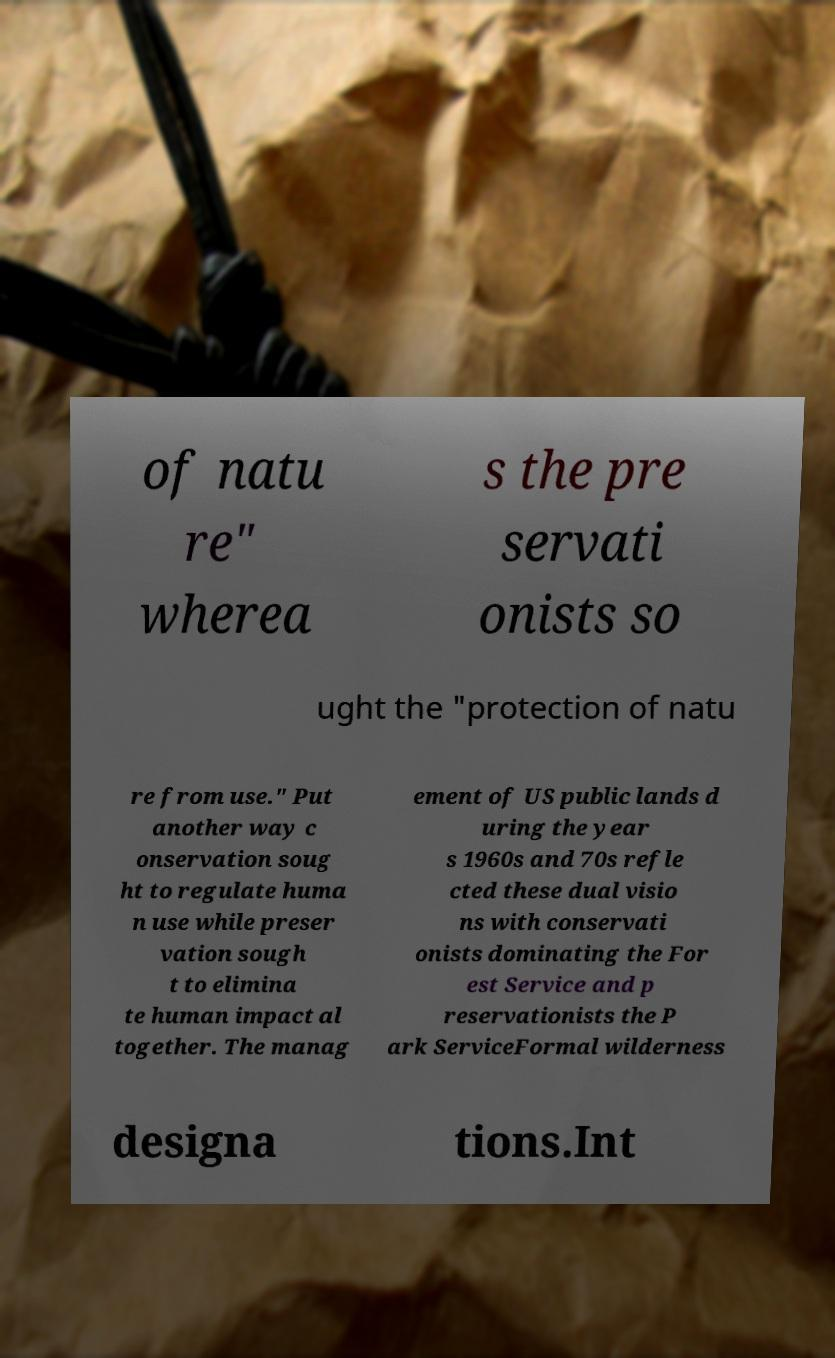For documentation purposes, I need the text within this image transcribed. Could you provide that? of natu re" wherea s the pre servati onists so ught the "protection of natu re from use." Put another way c onservation soug ht to regulate huma n use while preser vation sough t to elimina te human impact al together. The manag ement of US public lands d uring the year s 1960s and 70s refle cted these dual visio ns with conservati onists dominating the For est Service and p reservationists the P ark ServiceFormal wilderness designa tions.Int 